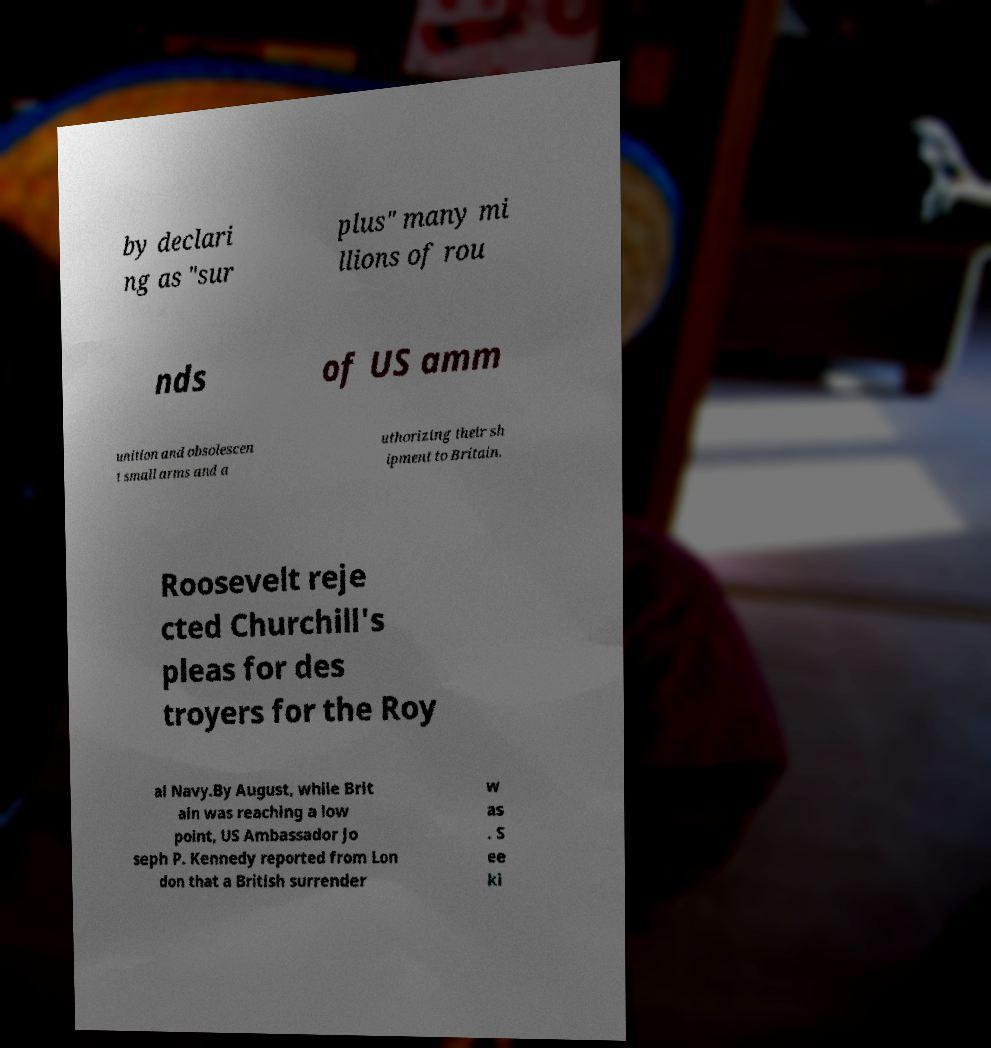Can you accurately transcribe the text from the provided image for me? by declari ng as "sur plus" many mi llions of rou nds of US amm unition and obsolescen t small arms and a uthorizing their sh ipment to Britain. Roosevelt reje cted Churchill's pleas for des troyers for the Roy al Navy.By August, while Brit ain was reaching a low point, US Ambassador Jo seph P. Kennedy reported from Lon don that a British surrender w as . S ee ki 